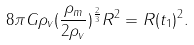<formula> <loc_0><loc_0><loc_500><loc_500>8 \pi G \rho _ { v } ( \frac { \rho _ { m } } { 2 \rho _ { v } } ) ^ { \frac { 2 } { 3 } } R ^ { 2 } = R ( t _ { 1 } ) ^ { 2 } .</formula> 